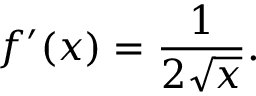<formula> <loc_0><loc_0><loc_500><loc_500>f ^ { \prime } ( x ) = { \frac { 1 } { 2 { \sqrt { x } } } } .</formula> 